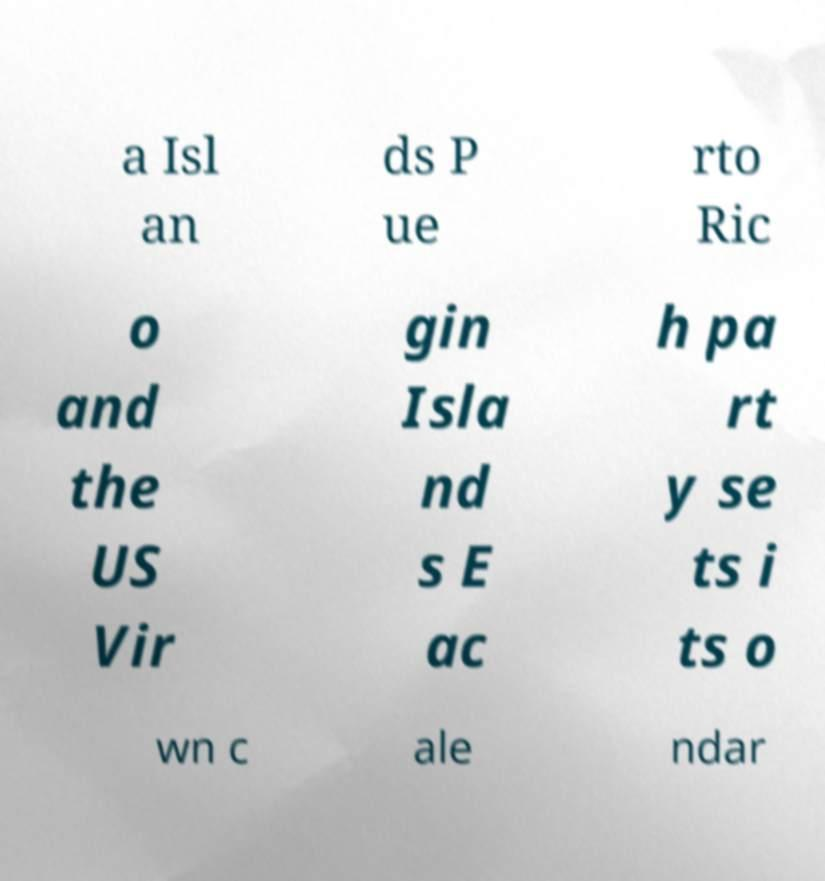Please identify and transcribe the text found in this image. a Isl an ds P ue rto Ric o and the US Vir gin Isla nd s E ac h pa rt y se ts i ts o wn c ale ndar 